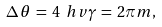Convert formula to latex. <formula><loc_0><loc_0><loc_500><loc_500>\Delta \, \theta \, = \, 4 \ h v \gamma \, = \, 2 \pi m ,</formula> 